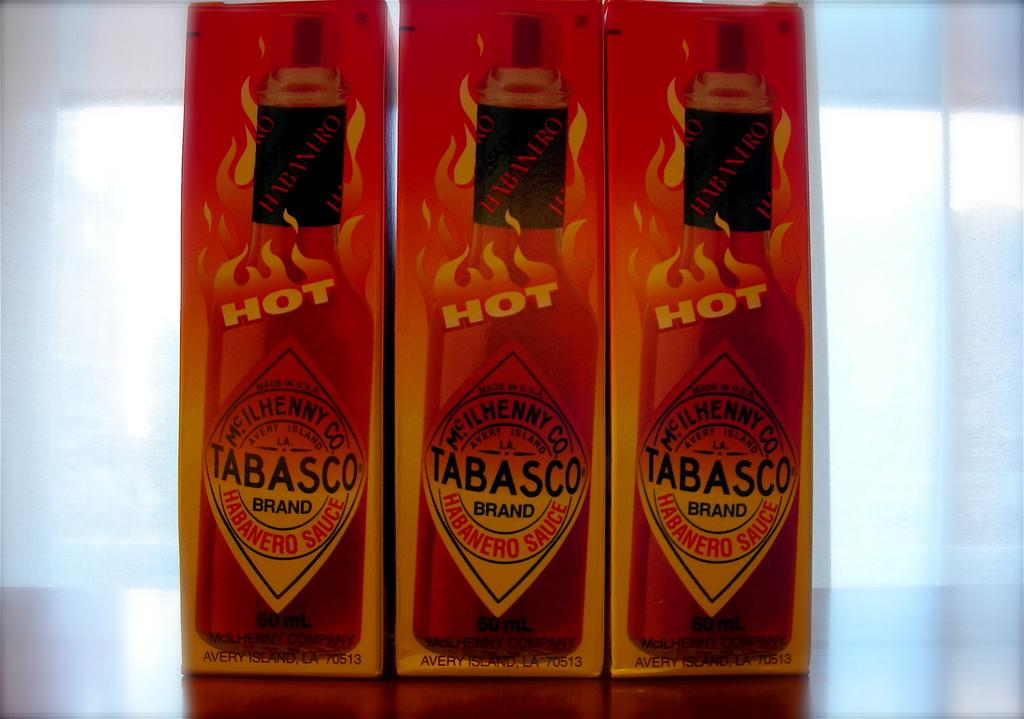<image>
Relay a brief, clear account of the picture shown. Row of three Tabasco hot sauce bottles labeled hot and containing 60 ml. 